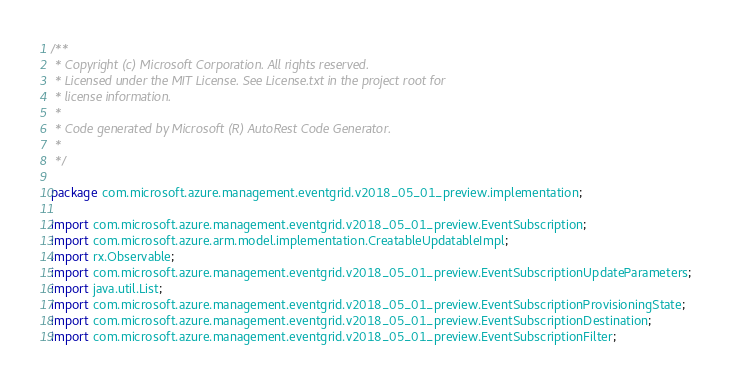<code> <loc_0><loc_0><loc_500><loc_500><_Java_>/**
 * Copyright (c) Microsoft Corporation. All rights reserved.
 * Licensed under the MIT License. See License.txt in the project root for
 * license information.
 *
 * Code generated by Microsoft (R) AutoRest Code Generator.
 *
 */

package com.microsoft.azure.management.eventgrid.v2018_05_01_preview.implementation;

import com.microsoft.azure.management.eventgrid.v2018_05_01_preview.EventSubscription;
import com.microsoft.azure.arm.model.implementation.CreatableUpdatableImpl;
import rx.Observable;
import com.microsoft.azure.management.eventgrid.v2018_05_01_preview.EventSubscriptionUpdateParameters;
import java.util.List;
import com.microsoft.azure.management.eventgrid.v2018_05_01_preview.EventSubscriptionProvisioningState;
import com.microsoft.azure.management.eventgrid.v2018_05_01_preview.EventSubscriptionDestination;
import com.microsoft.azure.management.eventgrid.v2018_05_01_preview.EventSubscriptionFilter;</code> 